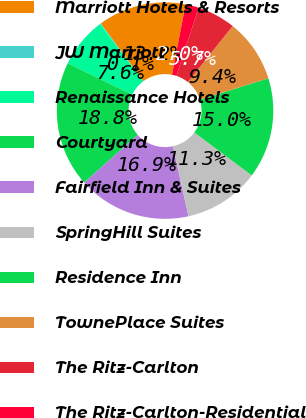Convert chart. <chart><loc_0><loc_0><loc_500><loc_500><pie_chart><fcel>Marriott Hotels & Resorts<fcel>JW Marriott<fcel>Renaissance Hotels<fcel>Courtyard<fcel>Fairfield Inn & Suites<fcel>SpringHill Suites<fcel>Residence Inn<fcel>TownePlace Suites<fcel>The Ritz-Carlton<fcel>The Ritz-Carlton-Residential<nl><fcel>13.17%<fcel>0.11%<fcel>7.57%<fcel>18.77%<fcel>16.9%<fcel>11.31%<fcel>15.04%<fcel>9.44%<fcel>5.71%<fcel>1.98%<nl></chart> 